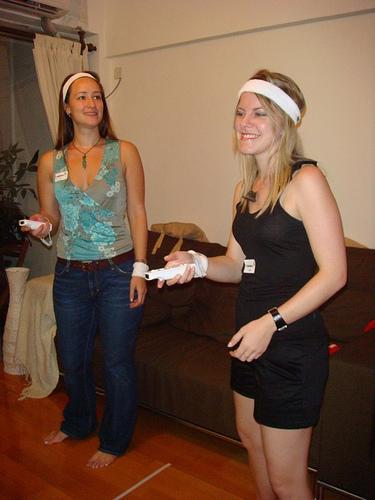What ethnicity are these women?
Be succinct. White. What are the white stickers on their clothing called?
Answer briefly. Name tags. Where are the curtains?
Give a very brief answer. Left. Does this lady paint her fingernails?
Quick response, please. Yes. What color is the woman's hair band?
Quick response, please. White. Is the women wearing shoes?
Answer briefly. No. 